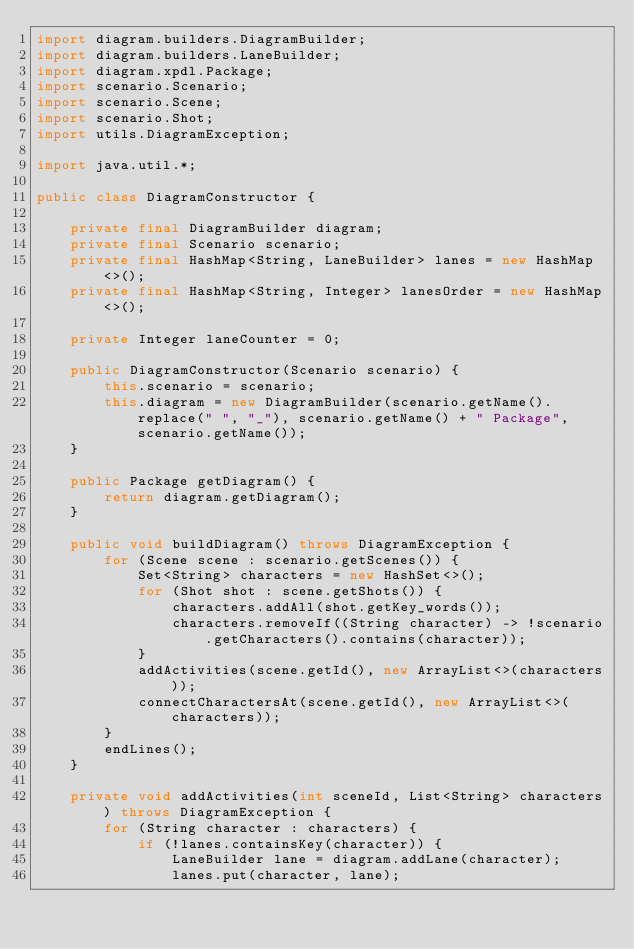<code> <loc_0><loc_0><loc_500><loc_500><_Java_>import diagram.builders.DiagramBuilder;
import diagram.builders.LaneBuilder;
import diagram.xpdl.Package;
import scenario.Scenario;
import scenario.Scene;
import scenario.Shot;
import utils.DiagramException;

import java.util.*;

public class DiagramConstructor {

    private final DiagramBuilder diagram;
    private final Scenario scenario;
    private final HashMap<String, LaneBuilder> lanes = new HashMap<>();
    private final HashMap<String, Integer> lanesOrder = new HashMap<>();

    private Integer laneCounter = 0;

    public DiagramConstructor(Scenario scenario) {
        this.scenario = scenario;
        this.diagram = new DiagramBuilder(scenario.getName().replace(" ", "_"), scenario.getName() + " Package", scenario.getName());
    }

    public Package getDiagram() {
        return diagram.getDiagram();
    }

    public void buildDiagram() throws DiagramException {
        for (Scene scene : scenario.getScenes()) {
            Set<String> characters = new HashSet<>();
            for (Shot shot : scene.getShots()) {
                characters.addAll(shot.getKey_words());
                characters.removeIf((String character) -> !scenario.getCharacters().contains(character));
            }
            addActivities(scene.getId(), new ArrayList<>(characters));
            connectCharactersAt(scene.getId(), new ArrayList<>(characters));
        }
        endLines();
    }

    private void addActivities(int sceneId, List<String> characters) throws DiagramException {
        for (String character : characters) {
            if (!lanes.containsKey(character)) {
                LaneBuilder lane = diagram.addLane(character);
                lanes.put(character, lane);</code> 